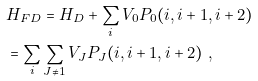Convert formula to latex. <formula><loc_0><loc_0><loc_500><loc_500>& H _ { F D } = H _ { D } + \sum _ { i } V _ { 0 } P _ { 0 } ( i , i + 1 , i + 2 ) \\ & = \sum _ { i } \sum _ { J \neq 1 } V _ { J } P _ { J } ( i , i + 1 , i + 2 ) \ ,</formula> 